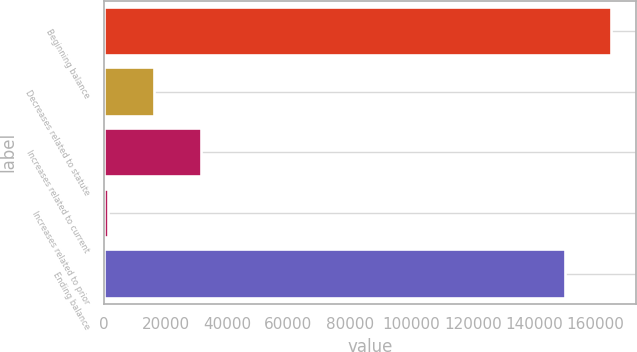Convert chart to OTSL. <chart><loc_0><loc_0><loc_500><loc_500><bar_chart><fcel>Beginning balance<fcel>Decreases related to statute<fcel>Increases related to current<fcel>Increases related to prior<fcel>Ending balance<nl><fcel>165052<fcel>16281.7<fcel>31455.4<fcel>1108<fcel>149878<nl></chart> 